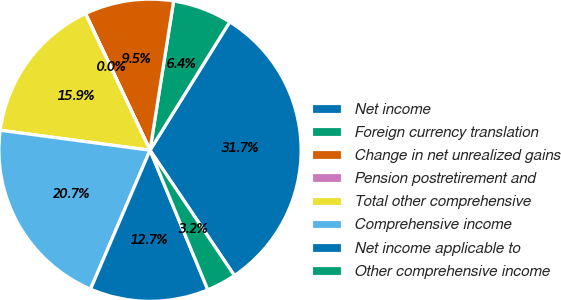Convert chart. <chart><loc_0><loc_0><loc_500><loc_500><pie_chart><fcel>Net income<fcel>Foreign currency translation<fcel>Change in net unrealized gains<fcel>Pension postretirement and<fcel>Total other comprehensive<fcel>Comprehensive income<fcel>Net income applicable to<fcel>Other comprehensive income<nl><fcel>31.72%<fcel>6.35%<fcel>9.52%<fcel>0.01%<fcel>15.86%<fcel>20.67%<fcel>12.69%<fcel>3.18%<nl></chart> 